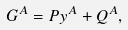Convert formula to latex. <formula><loc_0><loc_0><loc_500><loc_500>G ^ { A } = P y ^ { A } + Q ^ { A } ,</formula> 